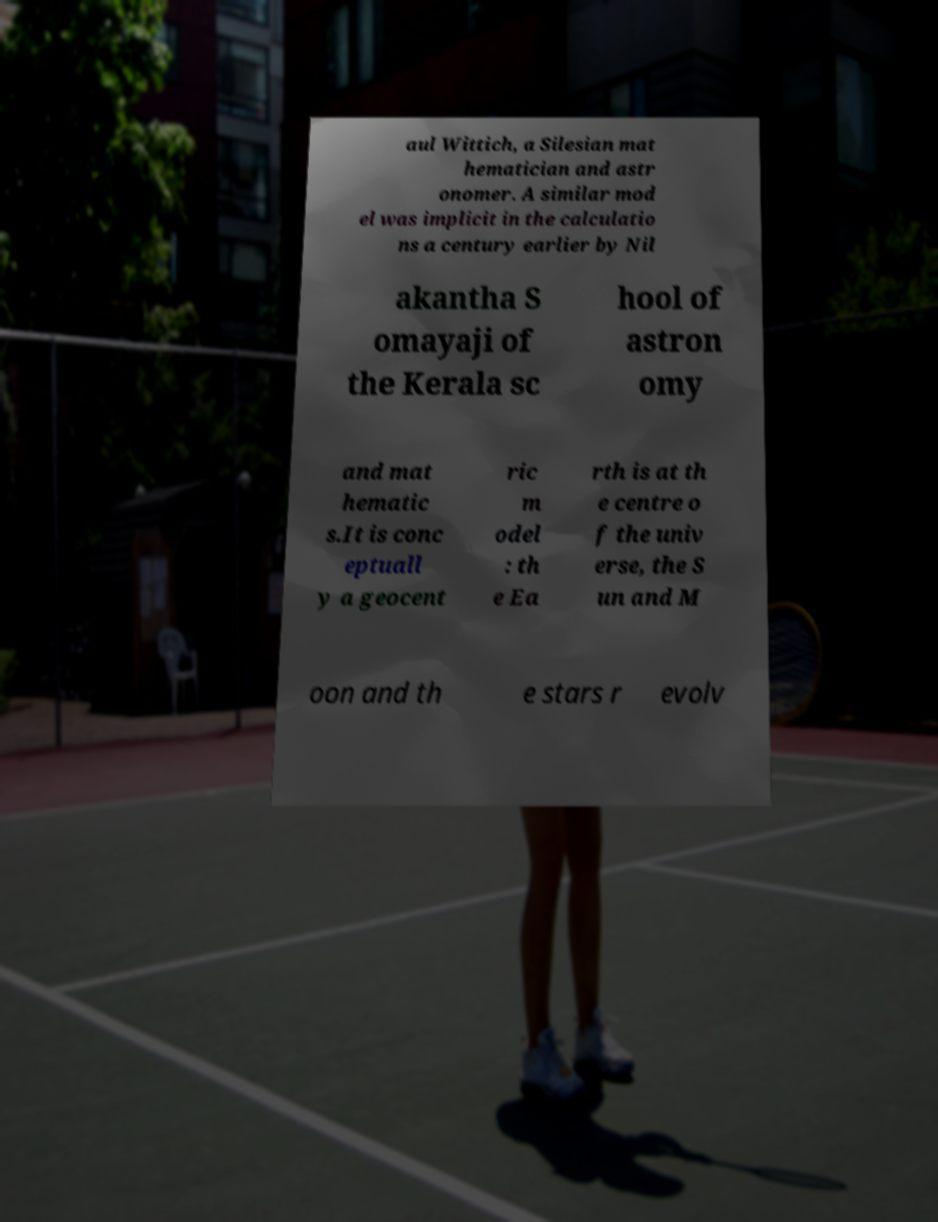Please read and relay the text visible in this image. What does it say? aul Wittich, a Silesian mat hematician and astr onomer. A similar mod el was implicit in the calculatio ns a century earlier by Nil akantha S omayaji of the Kerala sc hool of astron omy and mat hematic s.It is conc eptuall y a geocent ric m odel : th e Ea rth is at th e centre o f the univ erse, the S un and M oon and th e stars r evolv 